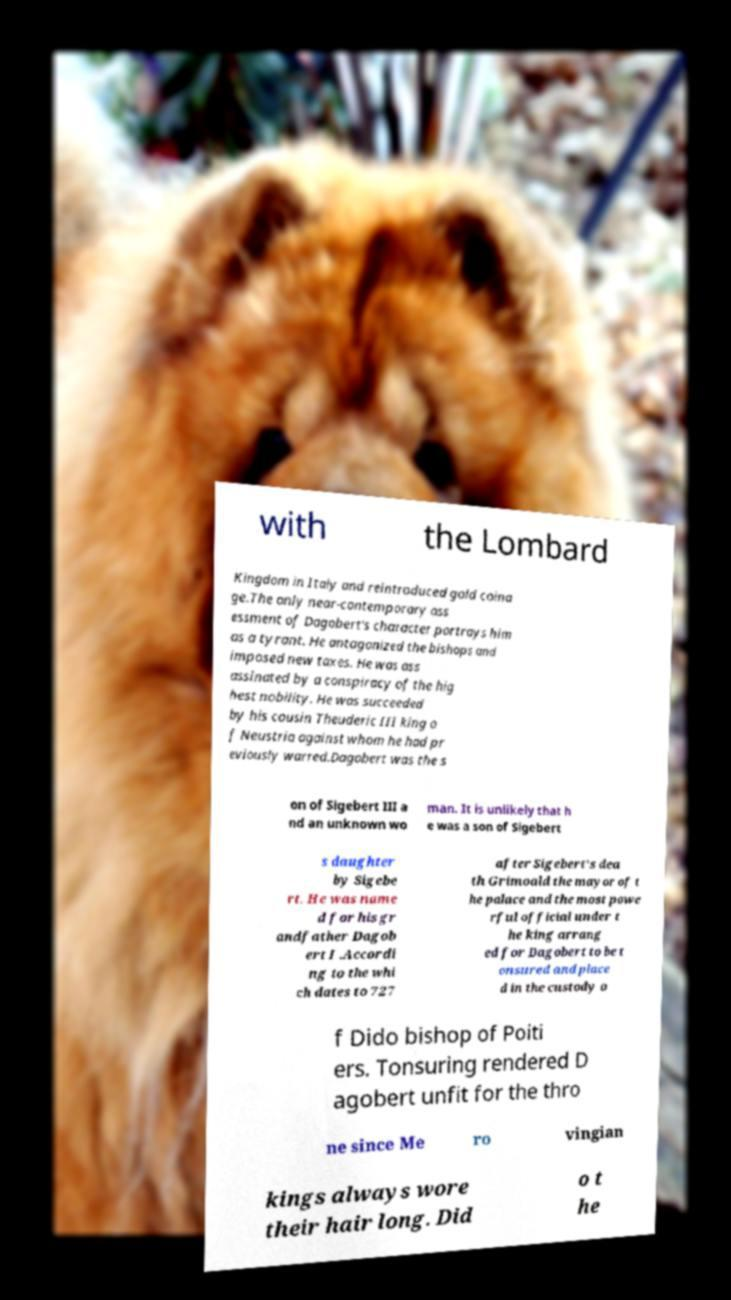Can you read and provide the text displayed in the image?This photo seems to have some interesting text. Can you extract and type it out for me? with the Lombard Kingdom in Italy and reintroduced gold coina ge.The only near-contemporary ass essment of Dagobert's character portrays him as a tyrant. He antagonized the bishops and imposed new taxes. He was ass assinated by a conspiracy of the hig hest nobility. He was succeeded by his cousin Theuderic III king o f Neustria against whom he had pr eviously warred.Dagobert was the s on of Sigebert III a nd an unknown wo man. It is unlikely that h e was a son of Sigebert s daughter by Sigebe rt. He was name d for his gr andfather Dagob ert I .Accordi ng to the whi ch dates to 727 after Sigebert's dea th Grimoald the mayor of t he palace and the most powe rful official under t he king arrang ed for Dagobert to be t onsured and place d in the custody o f Dido bishop of Poiti ers. Tonsuring rendered D agobert unfit for the thro ne since Me ro vingian kings always wore their hair long. Did o t he 